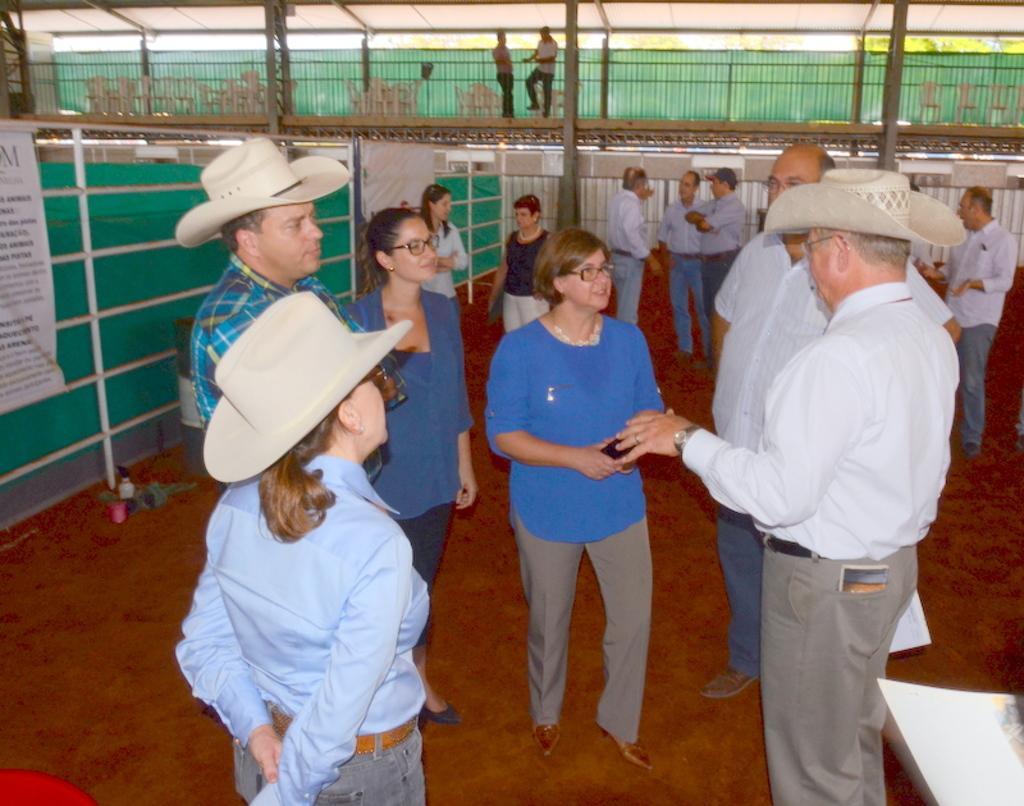How would you summarize this image in a sentence or two? In this picture there are group of people in the center. There is a man towards the right and he is wearing a white t shirt, grey trousers and a hat and he is facing towards the left. Before him there is a woman in blue top. Towards the left, there is a man and a woman wearing hats. In the background there are people and a bridge. 